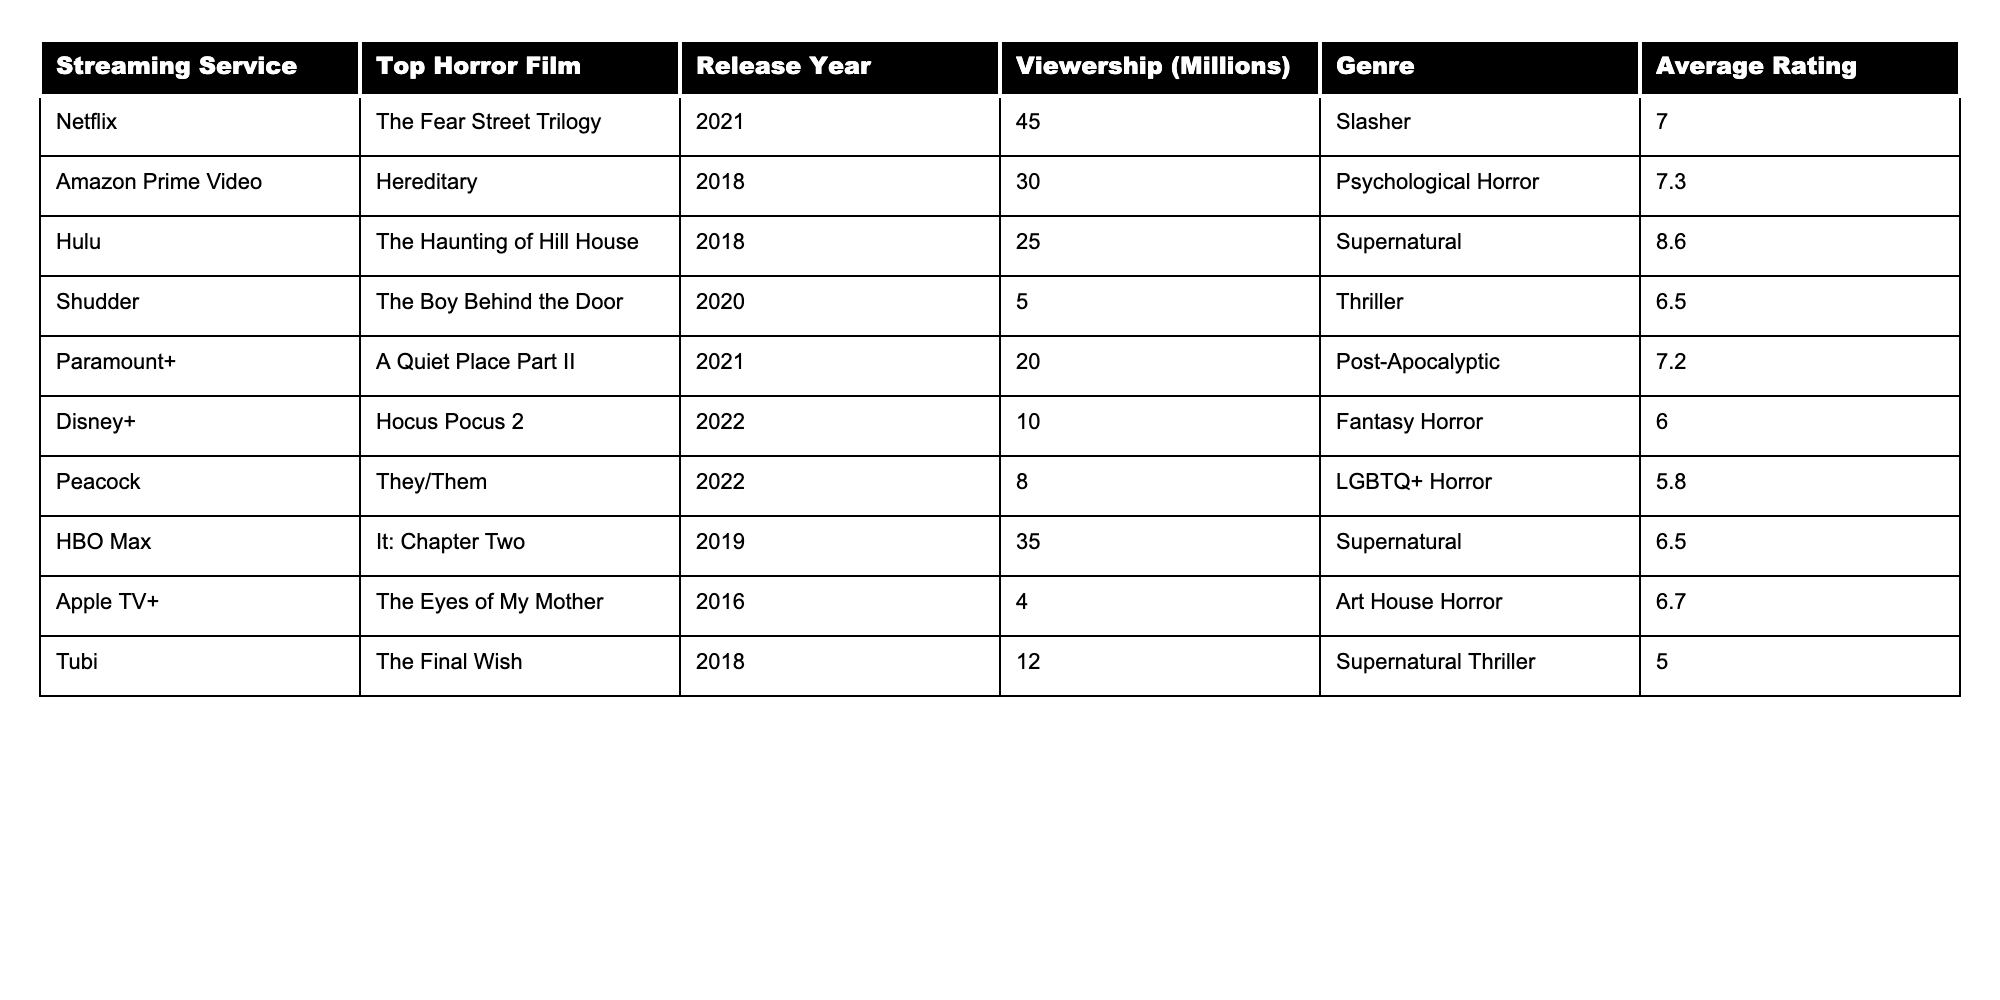What is the top horror film on Netflix according to the table? The table lists "The Fear Street Trilogy" as the top horror film on Netflix.
Answer: The Fear Street Trilogy Which streaming service has the highest viewership for horror films? By looking at the viewership values, Netflix has the highest viewership at 45 million.
Answer: Netflix What is the average rating of horror films on Amazon Prime Video? The table shows that "Hereditary" is the top horror film on Amazon Prime Video with an average rating of 7.3.
Answer: 7.3 How many millions of viewers does Hulu's top horror film have? "The Haunting of Hill House" has 25 million viewers according to the table.
Answer: 25 million Which horror film has the lowest viewership, and what is the number? The horror film "The Boy Behind the Door" on Shudder has the lowest viewership at 5 million.
Answer: The Boy Behind the Door, 5 million What is the average viewership of the top horror films from streaming services listed in the table? The total viewership is calculated as (45 + 30 + 25 + 5 + 20 + 10 + 8 + 35 + 4 + 12) = 189 million, divided by 10 films gives an average of 18.9 million.
Answer: 18.9 million Is "The Eyes of My Mother" the highest-rated film in the table? The average rating of "The Eyes of My Mother" is 6.7, which is not the highest, as "The Haunting of Hill House" has a higher rating of 8.6.
Answer: No Which film had more viewership: "A Quiet Place Part II" or "Hereditary"? "A Quiet Place Part II" has 20 million viewers, while "Hereditary" has 30 million viewers, thus "Hereditary" had more viewership.
Answer: Hereditary What genre does the highest-rated horror film in the table belong to? The highest-rated horror film is "The Haunting of Hill House," which belongs to the Supernatural genre.
Answer: Supernatural If you sum the viewership of all the horror films listed, what is the total? By adding each film's viewership: (45 + 30 + 25 + 5 + 20 + 10 + 8 + 35 + 4 + 12) equals 189 million viewers in total.
Answer: 189 million 